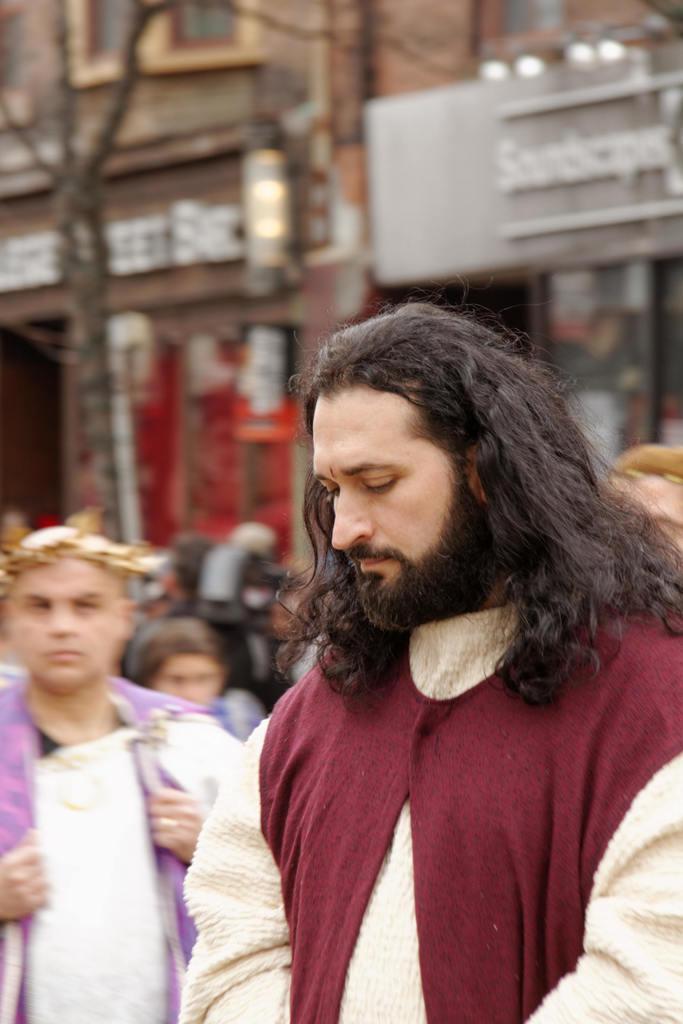Please provide a concise description of this image. In this image I can see group of people standing. In front the person is wearing cream and maroon color dress, background I can see few buildings in brown and gray color. 